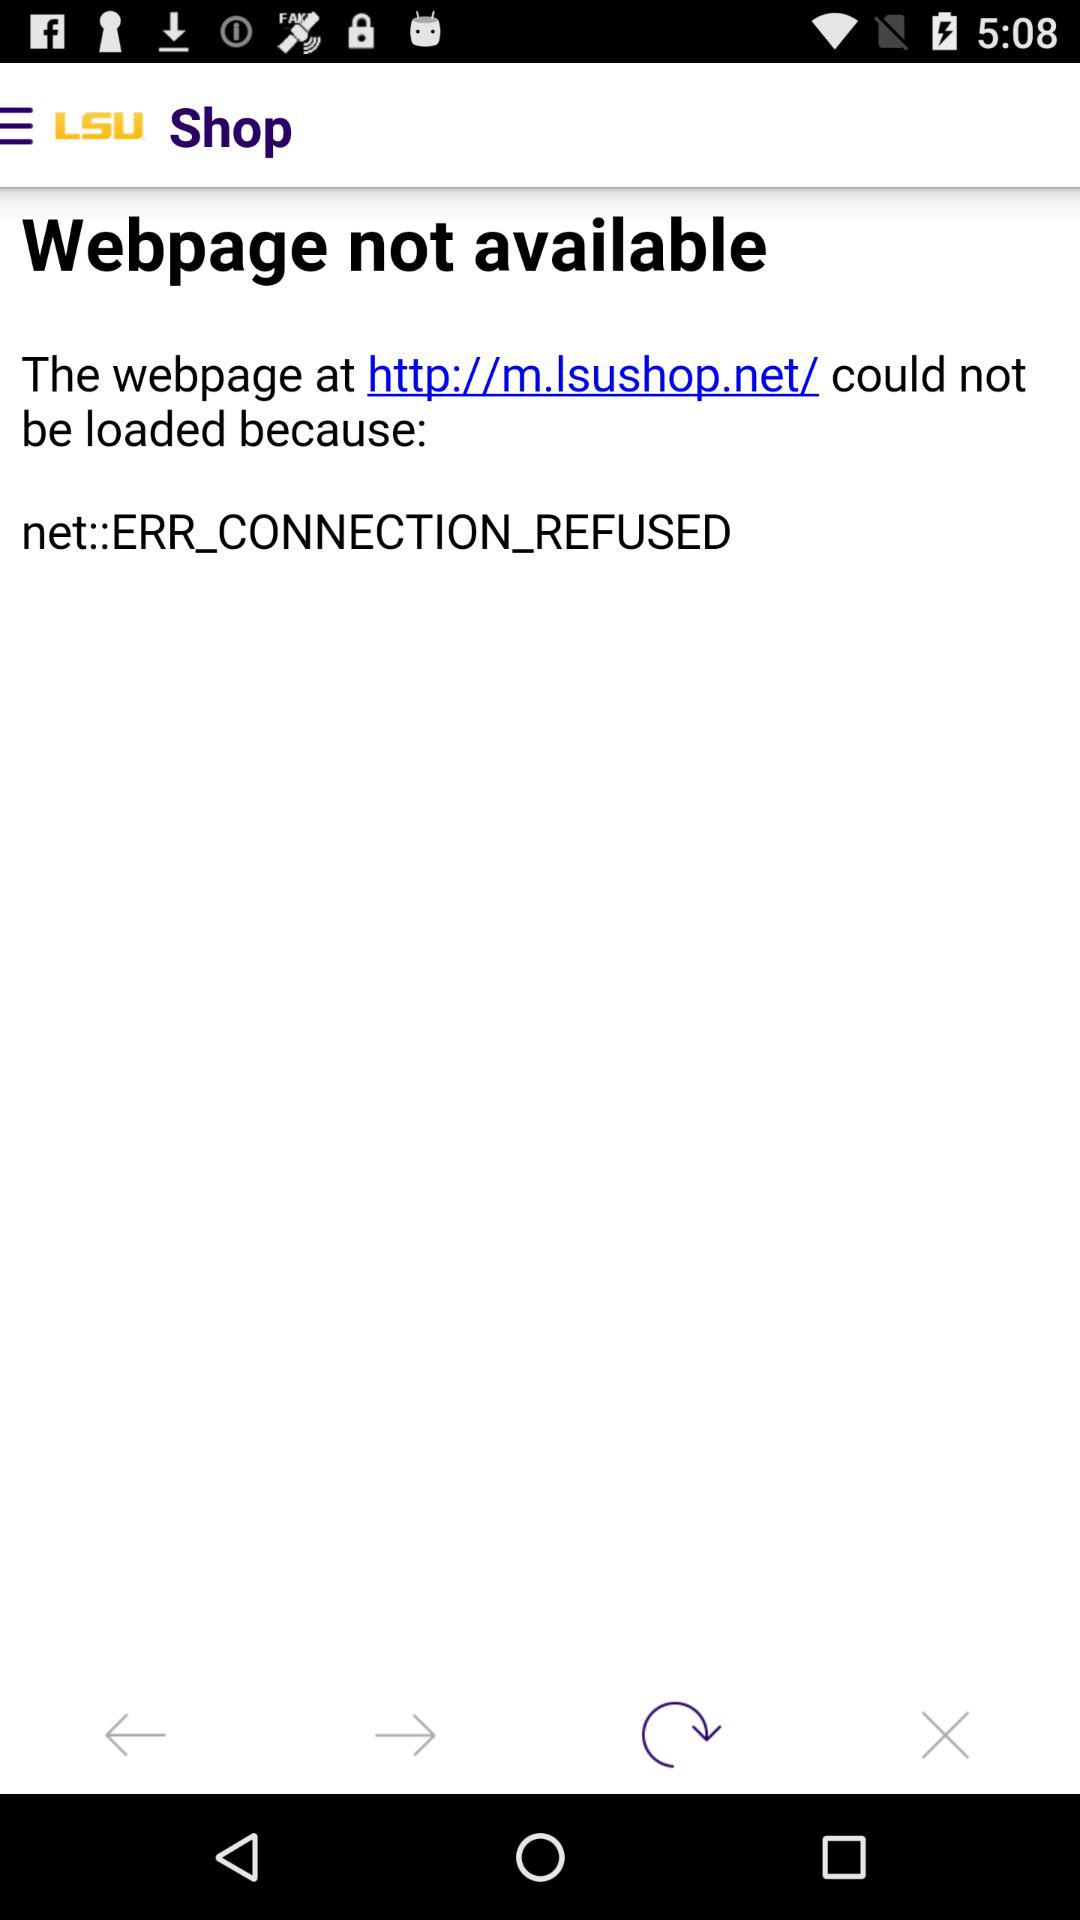What is the name of the application whose web page is unavailable? The name of the application whose web page is unavailable is "LSU". 